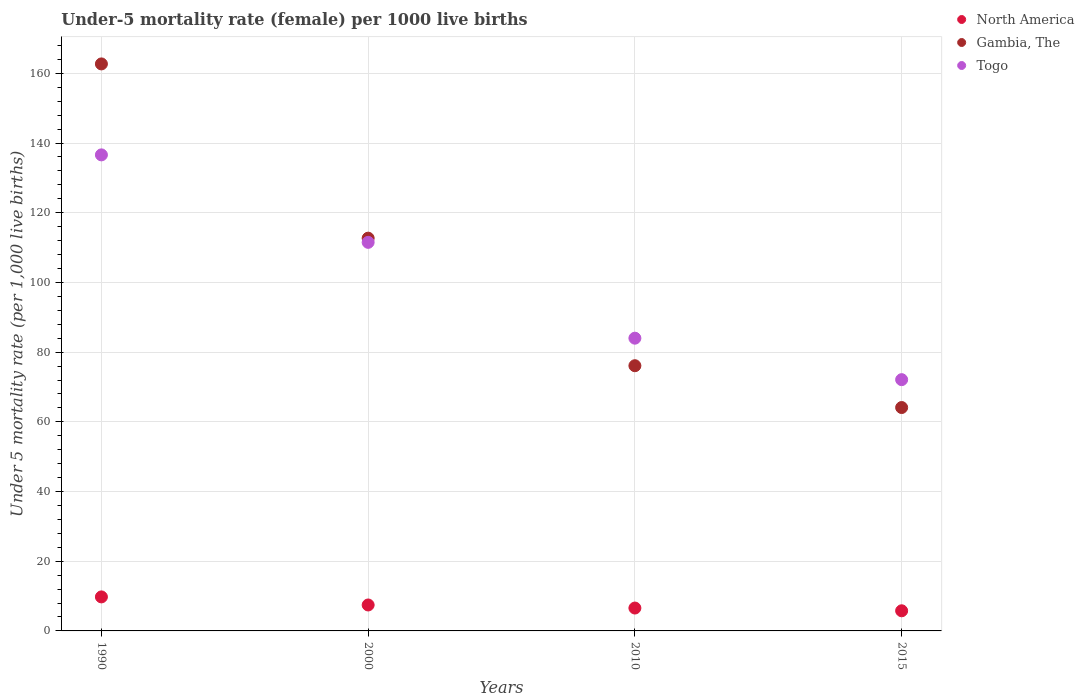How many different coloured dotlines are there?
Your answer should be compact. 3. Is the number of dotlines equal to the number of legend labels?
Your response must be concise. Yes. What is the under-five mortality rate in Togo in 2000?
Ensure brevity in your answer.  111.5. Across all years, what is the maximum under-five mortality rate in Togo?
Give a very brief answer. 136.6. Across all years, what is the minimum under-five mortality rate in North America?
Provide a short and direct response. 5.78. In which year was the under-five mortality rate in Togo maximum?
Keep it short and to the point. 1990. In which year was the under-five mortality rate in Togo minimum?
Keep it short and to the point. 2015. What is the total under-five mortality rate in Togo in the graph?
Ensure brevity in your answer.  404.2. What is the difference between the under-five mortality rate in North America in 2000 and that in 2010?
Provide a succinct answer. 0.88. What is the difference between the under-five mortality rate in Togo in 2015 and the under-five mortality rate in North America in 2000?
Ensure brevity in your answer.  64.65. What is the average under-five mortality rate in Togo per year?
Provide a short and direct response. 101.05. In the year 2010, what is the difference between the under-five mortality rate in North America and under-five mortality rate in Gambia, The?
Give a very brief answer. -69.54. What is the ratio of the under-five mortality rate in Gambia, The in 2000 to that in 2015?
Give a very brief answer. 1.76. Is the under-five mortality rate in North America in 1990 less than that in 2000?
Offer a very short reply. No. What is the difference between the highest and the second highest under-five mortality rate in Togo?
Ensure brevity in your answer.  25.1. What is the difference between the highest and the lowest under-five mortality rate in Togo?
Offer a terse response. 64.5. In how many years, is the under-five mortality rate in Gambia, The greater than the average under-five mortality rate in Gambia, The taken over all years?
Your response must be concise. 2. Does the under-five mortality rate in Togo monotonically increase over the years?
Provide a succinct answer. No. Is the under-five mortality rate in North America strictly less than the under-five mortality rate in Gambia, The over the years?
Your answer should be compact. Yes. What is the difference between two consecutive major ticks on the Y-axis?
Your answer should be compact. 20. Are the values on the major ticks of Y-axis written in scientific E-notation?
Ensure brevity in your answer.  No. Does the graph contain grids?
Keep it short and to the point. Yes. How many legend labels are there?
Your response must be concise. 3. What is the title of the graph?
Your response must be concise. Under-5 mortality rate (female) per 1000 live births. Does "Namibia" appear as one of the legend labels in the graph?
Your answer should be compact. No. What is the label or title of the Y-axis?
Give a very brief answer. Under 5 mortality rate (per 1,0 live births). What is the Under 5 mortality rate (per 1,000 live births) of North America in 1990?
Keep it short and to the point. 9.76. What is the Under 5 mortality rate (per 1,000 live births) in Gambia, The in 1990?
Your answer should be compact. 162.7. What is the Under 5 mortality rate (per 1,000 live births) in Togo in 1990?
Provide a short and direct response. 136.6. What is the Under 5 mortality rate (per 1,000 live births) of North America in 2000?
Provide a short and direct response. 7.45. What is the Under 5 mortality rate (per 1,000 live births) in Gambia, The in 2000?
Ensure brevity in your answer.  112.7. What is the Under 5 mortality rate (per 1,000 live births) in Togo in 2000?
Give a very brief answer. 111.5. What is the Under 5 mortality rate (per 1,000 live births) of North America in 2010?
Offer a very short reply. 6.56. What is the Under 5 mortality rate (per 1,000 live births) in Gambia, The in 2010?
Your answer should be very brief. 76.1. What is the Under 5 mortality rate (per 1,000 live births) in Togo in 2010?
Offer a terse response. 84. What is the Under 5 mortality rate (per 1,000 live births) in North America in 2015?
Give a very brief answer. 5.78. What is the Under 5 mortality rate (per 1,000 live births) of Gambia, The in 2015?
Make the answer very short. 64.1. What is the Under 5 mortality rate (per 1,000 live births) of Togo in 2015?
Give a very brief answer. 72.1. Across all years, what is the maximum Under 5 mortality rate (per 1,000 live births) of North America?
Give a very brief answer. 9.76. Across all years, what is the maximum Under 5 mortality rate (per 1,000 live births) in Gambia, The?
Offer a very short reply. 162.7. Across all years, what is the maximum Under 5 mortality rate (per 1,000 live births) of Togo?
Your answer should be very brief. 136.6. Across all years, what is the minimum Under 5 mortality rate (per 1,000 live births) of North America?
Keep it short and to the point. 5.78. Across all years, what is the minimum Under 5 mortality rate (per 1,000 live births) of Gambia, The?
Your answer should be compact. 64.1. Across all years, what is the minimum Under 5 mortality rate (per 1,000 live births) in Togo?
Give a very brief answer. 72.1. What is the total Under 5 mortality rate (per 1,000 live births) of North America in the graph?
Your answer should be compact. 29.55. What is the total Under 5 mortality rate (per 1,000 live births) in Gambia, The in the graph?
Your answer should be compact. 415.6. What is the total Under 5 mortality rate (per 1,000 live births) of Togo in the graph?
Make the answer very short. 404.2. What is the difference between the Under 5 mortality rate (per 1,000 live births) in North America in 1990 and that in 2000?
Ensure brevity in your answer.  2.31. What is the difference between the Under 5 mortality rate (per 1,000 live births) in Gambia, The in 1990 and that in 2000?
Offer a very short reply. 50. What is the difference between the Under 5 mortality rate (per 1,000 live births) in Togo in 1990 and that in 2000?
Offer a very short reply. 25.1. What is the difference between the Under 5 mortality rate (per 1,000 live births) in North America in 1990 and that in 2010?
Provide a succinct answer. 3.2. What is the difference between the Under 5 mortality rate (per 1,000 live births) in Gambia, The in 1990 and that in 2010?
Your answer should be very brief. 86.6. What is the difference between the Under 5 mortality rate (per 1,000 live births) in Togo in 1990 and that in 2010?
Keep it short and to the point. 52.6. What is the difference between the Under 5 mortality rate (per 1,000 live births) in North America in 1990 and that in 2015?
Provide a short and direct response. 3.98. What is the difference between the Under 5 mortality rate (per 1,000 live births) in Gambia, The in 1990 and that in 2015?
Give a very brief answer. 98.6. What is the difference between the Under 5 mortality rate (per 1,000 live births) in Togo in 1990 and that in 2015?
Ensure brevity in your answer.  64.5. What is the difference between the Under 5 mortality rate (per 1,000 live births) of North America in 2000 and that in 2010?
Provide a short and direct response. 0.88. What is the difference between the Under 5 mortality rate (per 1,000 live births) of Gambia, The in 2000 and that in 2010?
Keep it short and to the point. 36.6. What is the difference between the Under 5 mortality rate (per 1,000 live births) of Togo in 2000 and that in 2010?
Provide a succinct answer. 27.5. What is the difference between the Under 5 mortality rate (per 1,000 live births) of North America in 2000 and that in 2015?
Ensure brevity in your answer.  1.67. What is the difference between the Under 5 mortality rate (per 1,000 live births) of Gambia, The in 2000 and that in 2015?
Your response must be concise. 48.6. What is the difference between the Under 5 mortality rate (per 1,000 live births) of Togo in 2000 and that in 2015?
Your answer should be compact. 39.4. What is the difference between the Under 5 mortality rate (per 1,000 live births) of North America in 2010 and that in 2015?
Your answer should be very brief. 0.79. What is the difference between the Under 5 mortality rate (per 1,000 live births) of North America in 1990 and the Under 5 mortality rate (per 1,000 live births) of Gambia, The in 2000?
Provide a succinct answer. -102.94. What is the difference between the Under 5 mortality rate (per 1,000 live births) of North America in 1990 and the Under 5 mortality rate (per 1,000 live births) of Togo in 2000?
Your answer should be compact. -101.74. What is the difference between the Under 5 mortality rate (per 1,000 live births) in Gambia, The in 1990 and the Under 5 mortality rate (per 1,000 live births) in Togo in 2000?
Provide a succinct answer. 51.2. What is the difference between the Under 5 mortality rate (per 1,000 live births) in North America in 1990 and the Under 5 mortality rate (per 1,000 live births) in Gambia, The in 2010?
Provide a succinct answer. -66.34. What is the difference between the Under 5 mortality rate (per 1,000 live births) in North America in 1990 and the Under 5 mortality rate (per 1,000 live births) in Togo in 2010?
Offer a terse response. -74.24. What is the difference between the Under 5 mortality rate (per 1,000 live births) of Gambia, The in 1990 and the Under 5 mortality rate (per 1,000 live births) of Togo in 2010?
Ensure brevity in your answer.  78.7. What is the difference between the Under 5 mortality rate (per 1,000 live births) of North America in 1990 and the Under 5 mortality rate (per 1,000 live births) of Gambia, The in 2015?
Your response must be concise. -54.34. What is the difference between the Under 5 mortality rate (per 1,000 live births) in North America in 1990 and the Under 5 mortality rate (per 1,000 live births) in Togo in 2015?
Keep it short and to the point. -62.34. What is the difference between the Under 5 mortality rate (per 1,000 live births) of Gambia, The in 1990 and the Under 5 mortality rate (per 1,000 live births) of Togo in 2015?
Give a very brief answer. 90.6. What is the difference between the Under 5 mortality rate (per 1,000 live births) in North America in 2000 and the Under 5 mortality rate (per 1,000 live births) in Gambia, The in 2010?
Offer a terse response. -68.65. What is the difference between the Under 5 mortality rate (per 1,000 live births) in North America in 2000 and the Under 5 mortality rate (per 1,000 live births) in Togo in 2010?
Provide a succinct answer. -76.55. What is the difference between the Under 5 mortality rate (per 1,000 live births) of Gambia, The in 2000 and the Under 5 mortality rate (per 1,000 live births) of Togo in 2010?
Provide a short and direct response. 28.7. What is the difference between the Under 5 mortality rate (per 1,000 live births) in North America in 2000 and the Under 5 mortality rate (per 1,000 live births) in Gambia, The in 2015?
Offer a very short reply. -56.65. What is the difference between the Under 5 mortality rate (per 1,000 live births) of North America in 2000 and the Under 5 mortality rate (per 1,000 live births) of Togo in 2015?
Provide a succinct answer. -64.65. What is the difference between the Under 5 mortality rate (per 1,000 live births) in Gambia, The in 2000 and the Under 5 mortality rate (per 1,000 live births) in Togo in 2015?
Give a very brief answer. 40.6. What is the difference between the Under 5 mortality rate (per 1,000 live births) of North America in 2010 and the Under 5 mortality rate (per 1,000 live births) of Gambia, The in 2015?
Offer a terse response. -57.54. What is the difference between the Under 5 mortality rate (per 1,000 live births) of North America in 2010 and the Under 5 mortality rate (per 1,000 live births) of Togo in 2015?
Your response must be concise. -65.54. What is the difference between the Under 5 mortality rate (per 1,000 live births) in Gambia, The in 2010 and the Under 5 mortality rate (per 1,000 live births) in Togo in 2015?
Keep it short and to the point. 4. What is the average Under 5 mortality rate (per 1,000 live births) of North America per year?
Your response must be concise. 7.39. What is the average Under 5 mortality rate (per 1,000 live births) of Gambia, The per year?
Your answer should be very brief. 103.9. What is the average Under 5 mortality rate (per 1,000 live births) in Togo per year?
Offer a terse response. 101.05. In the year 1990, what is the difference between the Under 5 mortality rate (per 1,000 live births) in North America and Under 5 mortality rate (per 1,000 live births) in Gambia, The?
Provide a succinct answer. -152.94. In the year 1990, what is the difference between the Under 5 mortality rate (per 1,000 live births) in North America and Under 5 mortality rate (per 1,000 live births) in Togo?
Offer a terse response. -126.84. In the year 1990, what is the difference between the Under 5 mortality rate (per 1,000 live births) in Gambia, The and Under 5 mortality rate (per 1,000 live births) in Togo?
Your answer should be compact. 26.1. In the year 2000, what is the difference between the Under 5 mortality rate (per 1,000 live births) in North America and Under 5 mortality rate (per 1,000 live births) in Gambia, The?
Provide a succinct answer. -105.25. In the year 2000, what is the difference between the Under 5 mortality rate (per 1,000 live births) of North America and Under 5 mortality rate (per 1,000 live births) of Togo?
Your response must be concise. -104.05. In the year 2000, what is the difference between the Under 5 mortality rate (per 1,000 live births) in Gambia, The and Under 5 mortality rate (per 1,000 live births) in Togo?
Your answer should be compact. 1.2. In the year 2010, what is the difference between the Under 5 mortality rate (per 1,000 live births) of North America and Under 5 mortality rate (per 1,000 live births) of Gambia, The?
Offer a very short reply. -69.54. In the year 2010, what is the difference between the Under 5 mortality rate (per 1,000 live births) of North America and Under 5 mortality rate (per 1,000 live births) of Togo?
Make the answer very short. -77.44. In the year 2010, what is the difference between the Under 5 mortality rate (per 1,000 live births) in Gambia, The and Under 5 mortality rate (per 1,000 live births) in Togo?
Your answer should be compact. -7.9. In the year 2015, what is the difference between the Under 5 mortality rate (per 1,000 live births) of North America and Under 5 mortality rate (per 1,000 live births) of Gambia, The?
Make the answer very short. -58.32. In the year 2015, what is the difference between the Under 5 mortality rate (per 1,000 live births) in North America and Under 5 mortality rate (per 1,000 live births) in Togo?
Provide a succinct answer. -66.32. What is the ratio of the Under 5 mortality rate (per 1,000 live births) of North America in 1990 to that in 2000?
Provide a succinct answer. 1.31. What is the ratio of the Under 5 mortality rate (per 1,000 live births) of Gambia, The in 1990 to that in 2000?
Keep it short and to the point. 1.44. What is the ratio of the Under 5 mortality rate (per 1,000 live births) in Togo in 1990 to that in 2000?
Your answer should be compact. 1.23. What is the ratio of the Under 5 mortality rate (per 1,000 live births) of North America in 1990 to that in 2010?
Your answer should be very brief. 1.49. What is the ratio of the Under 5 mortality rate (per 1,000 live births) of Gambia, The in 1990 to that in 2010?
Your answer should be compact. 2.14. What is the ratio of the Under 5 mortality rate (per 1,000 live births) in Togo in 1990 to that in 2010?
Your answer should be compact. 1.63. What is the ratio of the Under 5 mortality rate (per 1,000 live births) in North America in 1990 to that in 2015?
Your answer should be very brief. 1.69. What is the ratio of the Under 5 mortality rate (per 1,000 live births) in Gambia, The in 1990 to that in 2015?
Make the answer very short. 2.54. What is the ratio of the Under 5 mortality rate (per 1,000 live births) in Togo in 1990 to that in 2015?
Make the answer very short. 1.89. What is the ratio of the Under 5 mortality rate (per 1,000 live births) in North America in 2000 to that in 2010?
Your response must be concise. 1.13. What is the ratio of the Under 5 mortality rate (per 1,000 live births) of Gambia, The in 2000 to that in 2010?
Your answer should be very brief. 1.48. What is the ratio of the Under 5 mortality rate (per 1,000 live births) of Togo in 2000 to that in 2010?
Your answer should be very brief. 1.33. What is the ratio of the Under 5 mortality rate (per 1,000 live births) in North America in 2000 to that in 2015?
Your answer should be compact. 1.29. What is the ratio of the Under 5 mortality rate (per 1,000 live births) of Gambia, The in 2000 to that in 2015?
Ensure brevity in your answer.  1.76. What is the ratio of the Under 5 mortality rate (per 1,000 live births) in Togo in 2000 to that in 2015?
Make the answer very short. 1.55. What is the ratio of the Under 5 mortality rate (per 1,000 live births) of North America in 2010 to that in 2015?
Keep it short and to the point. 1.14. What is the ratio of the Under 5 mortality rate (per 1,000 live births) in Gambia, The in 2010 to that in 2015?
Your answer should be very brief. 1.19. What is the ratio of the Under 5 mortality rate (per 1,000 live births) of Togo in 2010 to that in 2015?
Offer a terse response. 1.17. What is the difference between the highest and the second highest Under 5 mortality rate (per 1,000 live births) in North America?
Provide a short and direct response. 2.31. What is the difference between the highest and the second highest Under 5 mortality rate (per 1,000 live births) of Togo?
Offer a very short reply. 25.1. What is the difference between the highest and the lowest Under 5 mortality rate (per 1,000 live births) in North America?
Give a very brief answer. 3.98. What is the difference between the highest and the lowest Under 5 mortality rate (per 1,000 live births) of Gambia, The?
Offer a terse response. 98.6. What is the difference between the highest and the lowest Under 5 mortality rate (per 1,000 live births) in Togo?
Give a very brief answer. 64.5. 